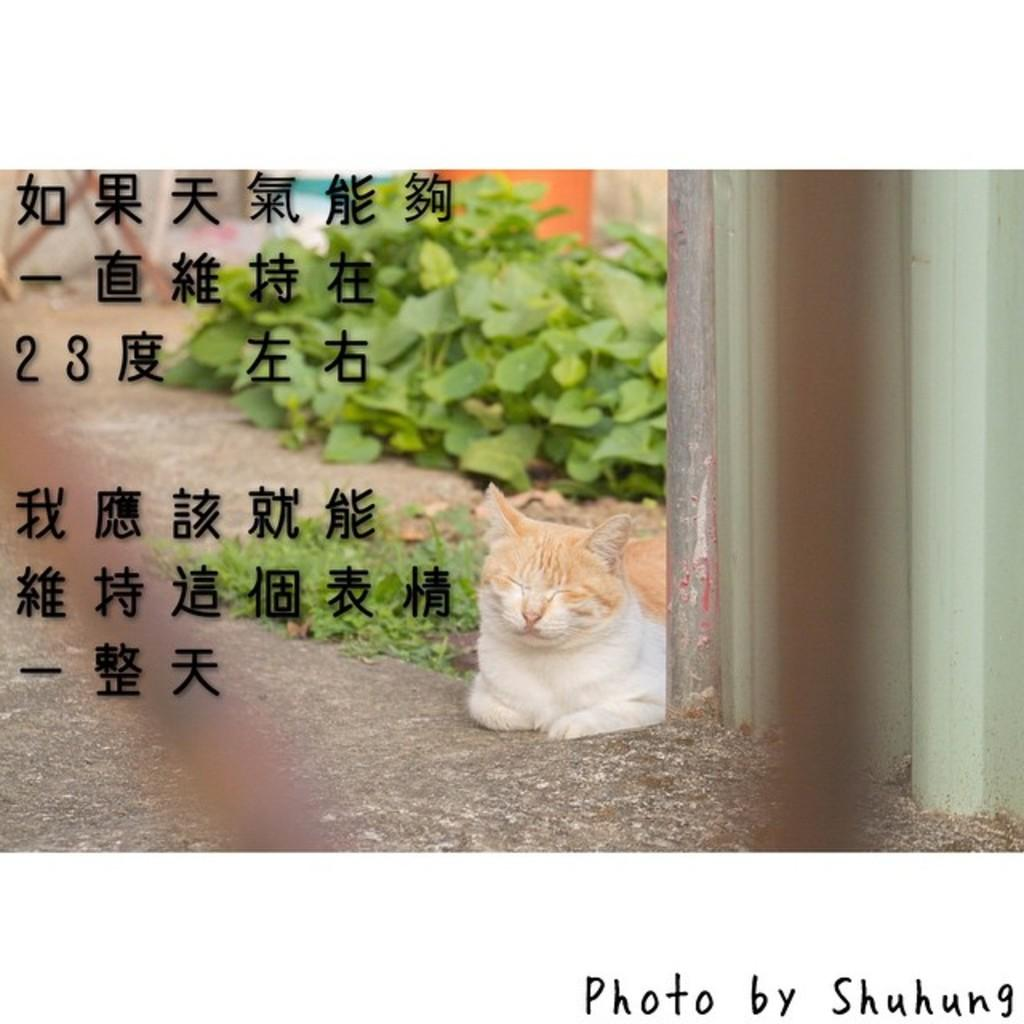What animal can be seen on the ground in the image? There is a cat on the ground in the image. What vertical structure is present in the image? There is a pole in the image. What type of surface is visible in the image? There is a wall in the image. What type of vegetation is present in the image? There are plants and grass in the image. What additional feature can be seen on the image? There is text on the image. How many arms does the cat have in the image? Cats do not have arms; they have legs. In the image, the cat has four legs. 